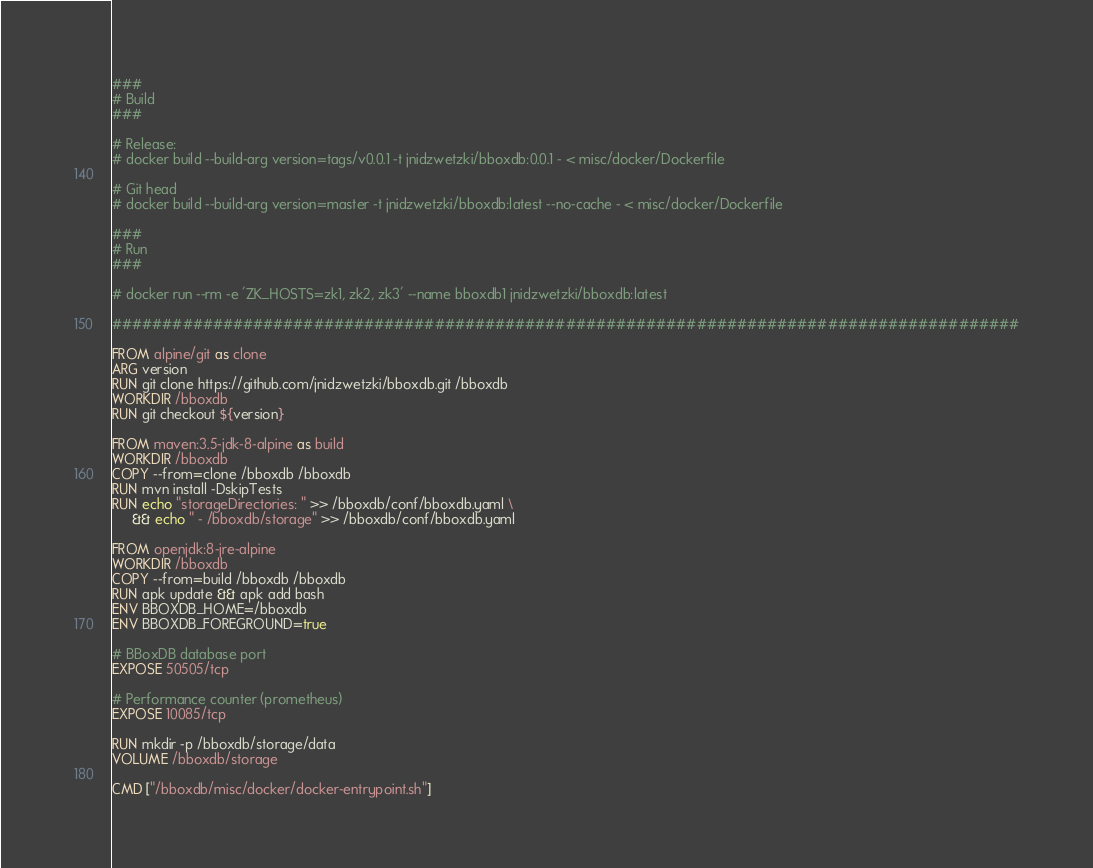<code> <loc_0><loc_0><loc_500><loc_500><_Dockerfile_>###
# Build
###

# Release:
# docker build --build-arg version=tags/v0.0.1 -t jnidzwetzki/bboxdb:0.0.1 - < misc/docker/Dockerfile

# Git head
# docker build --build-arg version=master -t jnidzwetzki/bboxdb:latest --no-cache - < misc/docker/Dockerfile

###
# Run
###

# docker run --rm -e 'ZK_HOSTS=zk1, zk2, zk3' --name bboxdb1 jnidzwetzki/bboxdb:latest

##########################################################################################

FROM alpine/git as clone
ARG version
RUN git clone https://github.com/jnidzwetzki/bboxdb.git /bboxdb
WORKDIR /bboxdb
RUN git checkout ${version}

FROM maven:3.5-jdk-8-alpine as build
WORKDIR /bboxdb
COPY --from=clone /bboxdb /bboxdb
RUN mvn install -DskipTests
RUN echo "storageDirectories: " >> /bboxdb/conf/bboxdb.yaml \
     && echo " - /bboxdb/storage" >> /bboxdb/conf/bboxdb.yaml

FROM openjdk:8-jre-alpine
WORKDIR /bboxdb
COPY --from=build /bboxdb /bboxdb
RUN apk update && apk add bash
ENV BBOXDB_HOME=/bboxdb
ENV BBOXDB_FOREGROUND=true

# BBoxDB database port
EXPOSE 50505/tcp

# Performance counter (prometheus)
EXPOSE 10085/tcp

RUN mkdir -p /bboxdb/storage/data
VOLUME /bboxdb/storage

CMD ["/bboxdb/misc/docker/docker-entrypoint.sh"]
</code> 